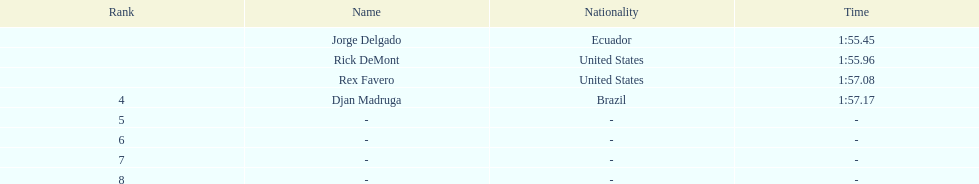After rex f., what comes next? Djan Madruga. 